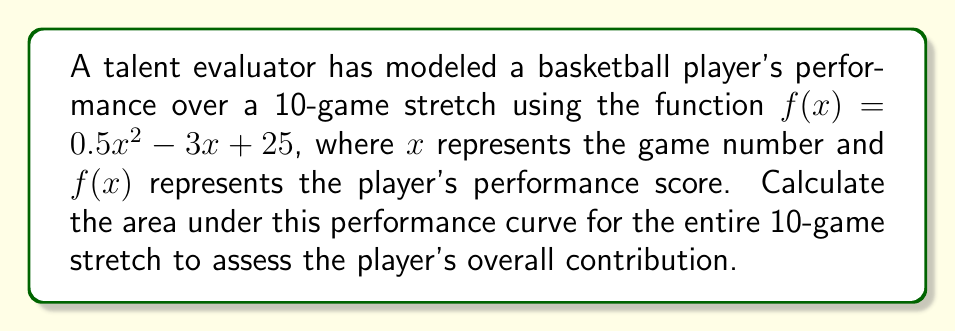What is the answer to this math problem? To calculate the area under the performance curve, we need to use a definite integral. The area will be represented by the integral of $f(x)$ from $x=1$ to $x=10$.

1) Set up the definite integral:
   $$\int_{1}^{10} (0.5x^2 - 3x + 25) dx$$

2) Integrate the function:
   $$\left[ \frac{1}{6}x^3 - \frac{3}{2}x^2 + 25x \right]_{1}^{10}$$

3) Evaluate the integral at the upper and lower bounds:
   $$\left(\frac{1}{6}(10^3) - \frac{3}{2}(10^2) + 25(10)\right) - \left(\frac{1}{6}(1^3) - \frac{3}{2}(1^2) + 25(1)\right)$$

4) Simplify:
   $$\left(\frac{1000}{6} - 150 + 250\right) - \left(\frac{1}{6} - \frac{3}{2} + 25\right)$$
   
   $$\left(\frac{1000}{6} + 100\right) - \left(\frac{23.5}{6}\right)$$
   
   $$\frac{1000}{6} + 100 - \frac{23.5}{6}$$
   
   $$\frac{976.5}{6} + 100$$
   
   $$162.75 + 100 = 262.75$$

Therefore, the area under the performance curve for the 10-game stretch is 262.75 performance units.
Answer: 262.75 performance units 